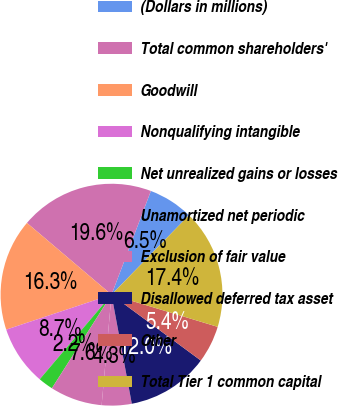Convert chart to OTSL. <chart><loc_0><loc_0><loc_500><loc_500><pie_chart><fcel>(Dollars in millions)<fcel>Total common shareholders'<fcel>Goodwill<fcel>Nonqualifying intangible<fcel>Net unrealized gains or losses<fcel>Unamortized net periodic<fcel>Exclusion of fair value<fcel>Disallowed deferred tax asset<fcel>Other<fcel>Total Tier 1 common capital<nl><fcel>6.52%<fcel>19.57%<fcel>16.3%<fcel>8.7%<fcel>2.17%<fcel>7.61%<fcel>4.35%<fcel>11.96%<fcel>5.43%<fcel>17.39%<nl></chart> 